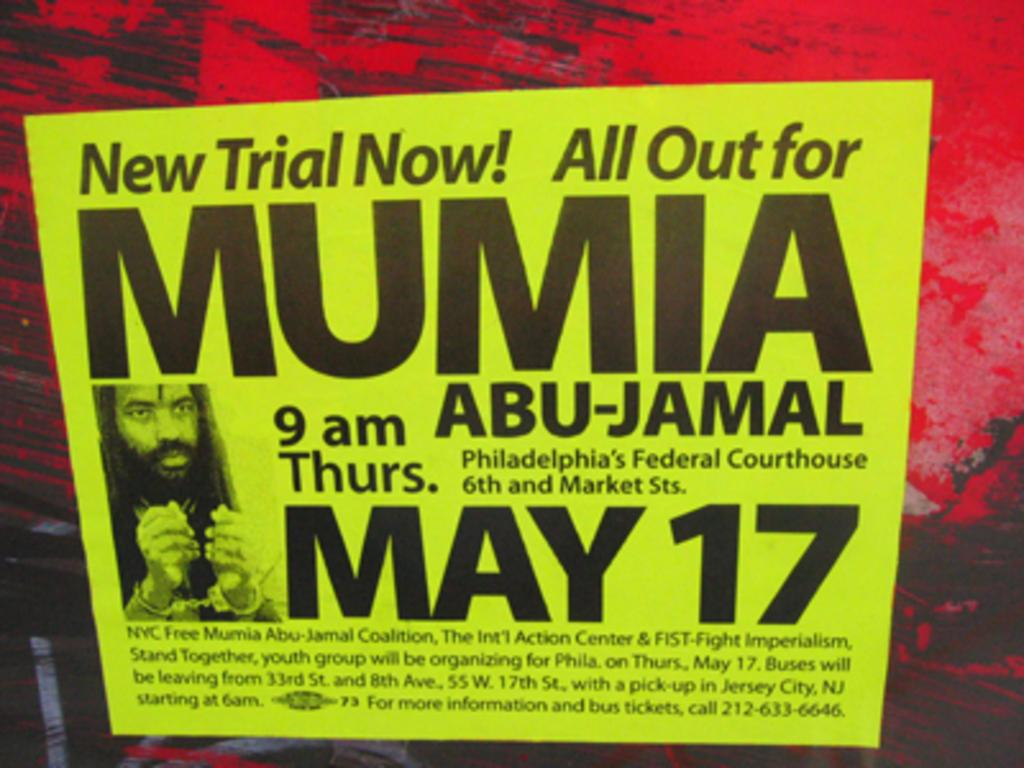<image>
Provide a brief description of the given image. A neon yellow poster that titles New Trail Now! All ut for Mumia 